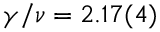Convert formula to latex. <formula><loc_0><loc_0><loc_500><loc_500>\gamma / \nu = 2 . 1 7 ( 4 )</formula> 